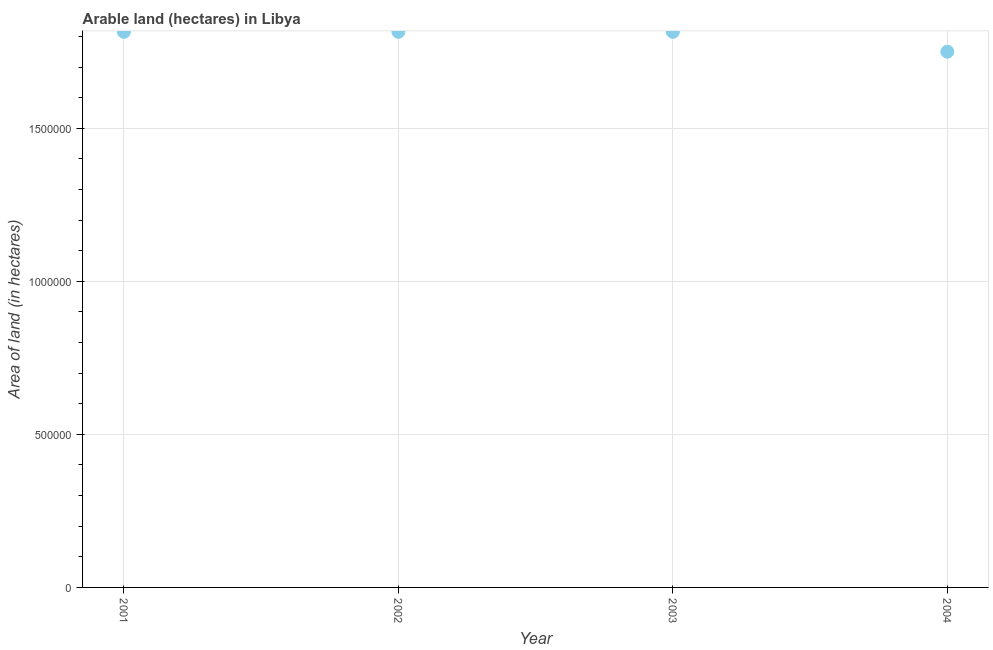What is the area of land in 2002?
Ensure brevity in your answer.  1.82e+06. Across all years, what is the maximum area of land?
Make the answer very short. 1.82e+06. Across all years, what is the minimum area of land?
Keep it short and to the point. 1.75e+06. In which year was the area of land maximum?
Provide a short and direct response. 2001. In which year was the area of land minimum?
Ensure brevity in your answer.  2004. What is the sum of the area of land?
Keep it short and to the point. 7.20e+06. What is the difference between the area of land in 2003 and 2004?
Your answer should be compact. 6.50e+04. What is the average area of land per year?
Give a very brief answer. 1.80e+06. What is the median area of land?
Your answer should be very brief. 1.82e+06. What is the ratio of the area of land in 2003 to that in 2004?
Your answer should be compact. 1.04. Is the difference between the area of land in 2001 and 2004 greater than the difference between any two years?
Keep it short and to the point. Yes. What is the difference between the highest and the second highest area of land?
Ensure brevity in your answer.  0. Is the sum of the area of land in 2003 and 2004 greater than the maximum area of land across all years?
Provide a succinct answer. Yes. What is the difference between the highest and the lowest area of land?
Ensure brevity in your answer.  6.50e+04. Does the area of land monotonically increase over the years?
Keep it short and to the point. No. How many dotlines are there?
Your answer should be compact. 1. How many years are there in the graph?
Provide a succinct answer. 4. Are the values on the major ticks of Y-axis written in scientific E-notation?
Offer a very short reply. No. Does the graph contain any zero values?
Your answer should be very brief. No. Does the graph contain grids?
Offer a terse response. Yes. What is the title of the graph?
Provide a short and direct response. Arable land (hectares) in Libya. What is the label or title of the X-axis?
Ensure brevity in your answer.  Year. What is the label or title of the Y-axis?
Offer a terse response. Area of land (in hectares). What is the Area of land (in hectares) in 2001?
Keep it short and to the point. 1.82e+06. What is the Area of land (in hectares) in 2002?
Offer a terse response. 1.82e+06. What is the Area of land (in hectares) in 2003?
Offer a terse response. 1.82e+06. What is the Area of land (in hectares) in 2004?
Make the answer very short. 1.75e+06. What is the difference between the Area of land (in hectares) in 2001 and 2002?
Your answer should be compact. 0. What is the difference between the Area of land (in hectares) in 2001 and 2003?
Give a very brief answer. 0. What is the difference between the Area of land (in hectares) in 2001 and 2004?
Offer a terse response. 6.50e+04. What is the difference between the Area of land (in hectares) in 2002 and 2003?
Offer a very short reply. 0. What is the difference between the Area of land (in hectares) in 2002 and 2004?
Provide a succinct answer. 6.50e+04. What is the difference between the Area of land (in hectares) in 2003 and 2004?
Offer a very short reply. 6.50e+04. What is the ratio of the Area of land (in hectares) in 2001 to that in 2004?
Your answer should be compact. 1.04. 